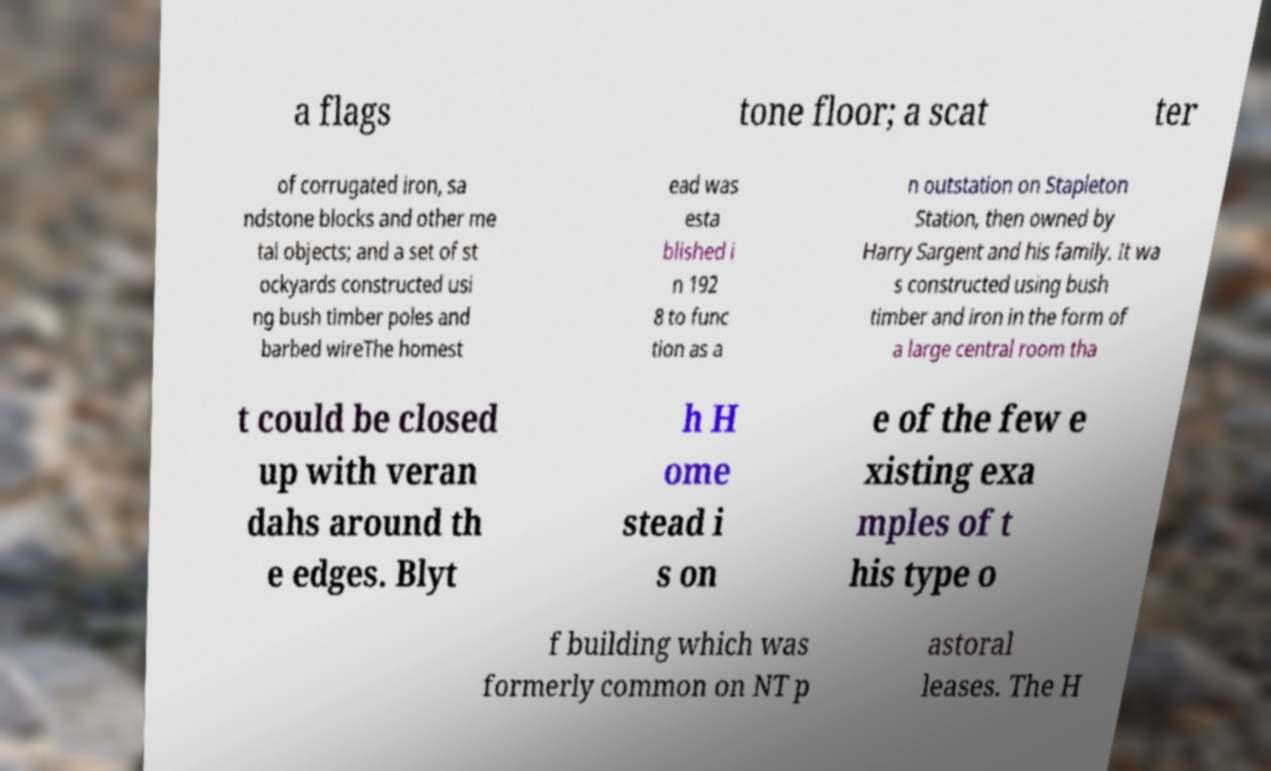Can you accurately transcribe the text from the provided image for me? a flags tone floor; a scat ter of corrugated iron, sa ndstone blocks and other me tal objects; and a set of st ockyards constructed usi ng bush timber poles and barbed wireThe homest ead was esta blished i n 192 8 to func tion as a n outstation on Stapleton Station, then owned by Harry Sargent and his family. It wa s constructed using bush timber and iron in the form of a large central room tha t could be closed up with veran dahs around th e edges. Blyt h H ome stead i s on e of the few e xisting exa mples of t his type o f building which was formerly common on NT p astoral leases. The H 